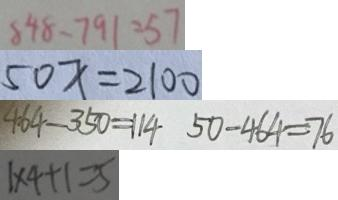Convert formula to latex. <formula><loc_0><loc_0><loc_500><loc_500>8 4 8 - 7 9 1 = 5 7 
 5 0 x = 2 1 0 0 
 4 6 4 - 3 5 0 = 1 1 4 5 0 - 4 6 4 = 7 6 
 1 \times 4 + 1 = 5</formula> 